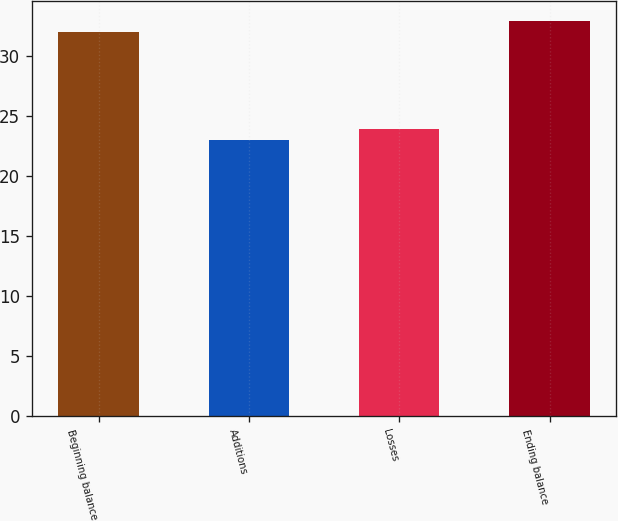<chart> <loc_0><loc_0><loc_500><loc_500><bar_chart><fcel>Beginning balance<fcel>Additions<fcel>Losses<fcel>Ending balance<nl><fcel>32<fcel>23<fcel>23.9<fcel>32.9<nl></chart> 